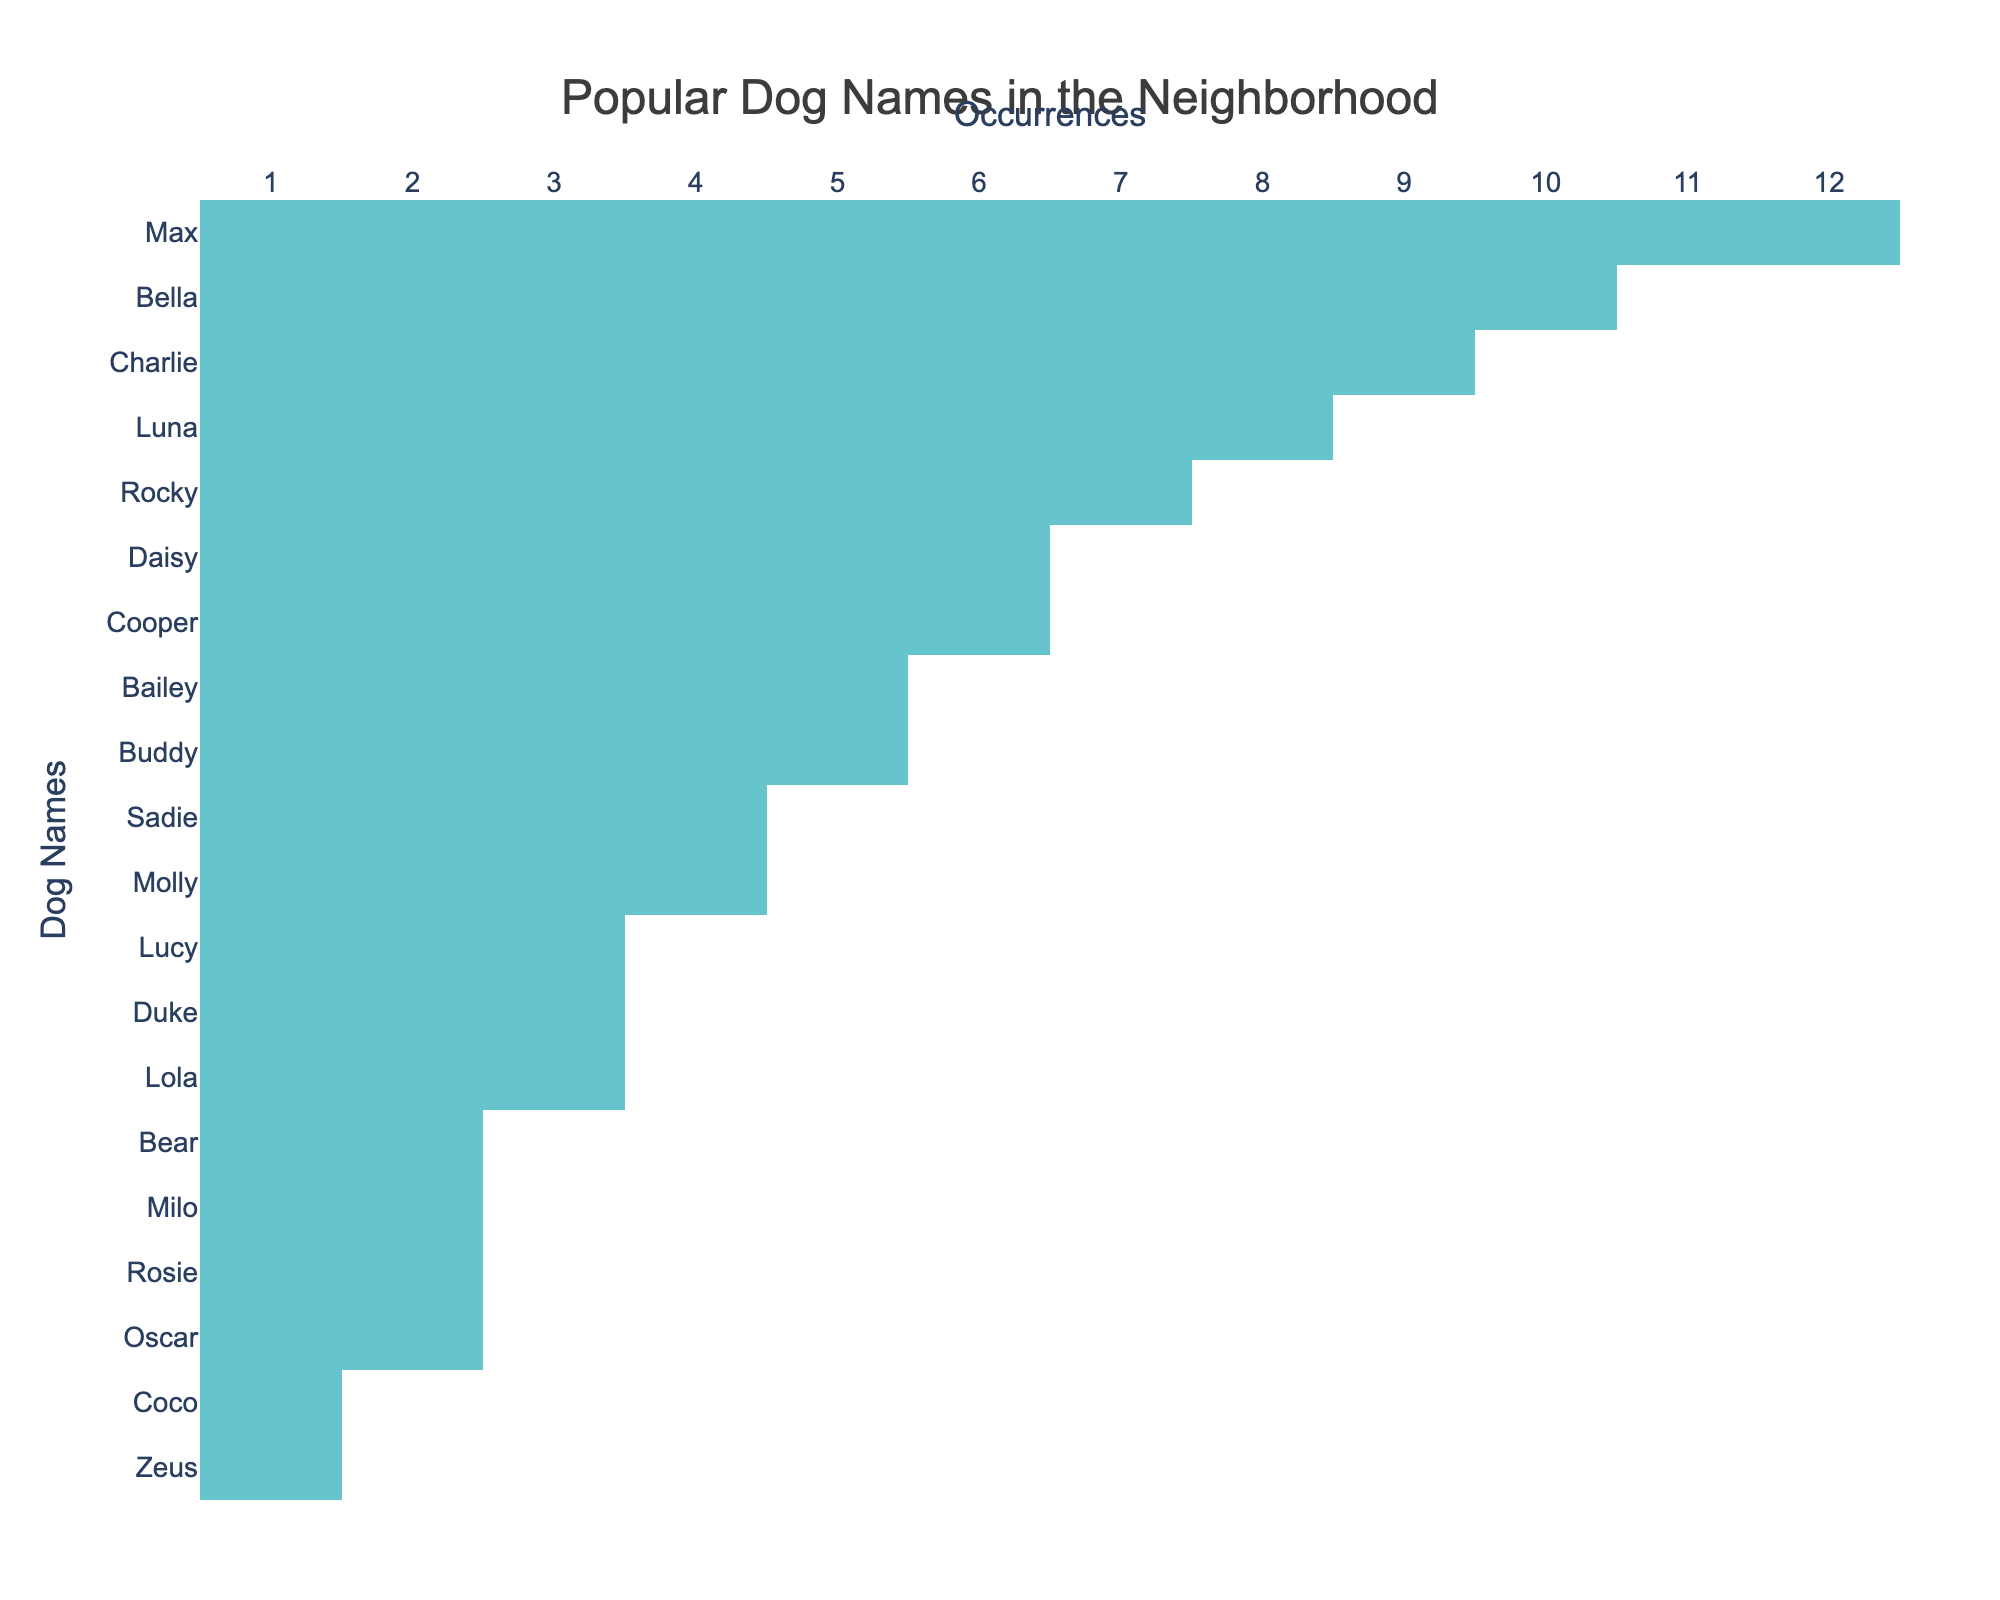What is the most popular dog name in the neighborhood? The table shows that "Max" has the highest occurrence at 12, making it the most popular dog name.
Answer: Max How many dogs have names that occur five times or more? By counting the occurrences of names with 5 or more, we see that there are 7 names: Max, Bella, Charlie, Luna, Rocky, Daisy, and Cooper.
Answer: 7 Is "Oscar" one of the top five most common dog names? Looking at the occurrences, "Oscar" has 2 occurrences, which does not place it in the top five names.
Answer: No What is the total number of occurrences of the dog names that end with the letter 'y'? The names ending with 'y' are Bailey, Buddy, and Daisy. Their occurrences are 5, 5, and 6, respectively. Adding these gives total occurrences as 5 + 5 + 6 = 16.
Answer: 16 What is the difference in occurrences between the most popular and the least popular dog name? The most popular name is "Max" with 12 occurrences and the least popular is "Coco" with 1 occurrence. The difference is 12 - 1 = 11.
Answer: 11 How many names have occurrences of less than 3? The names with occurrences less than 3 are "Coco" and "Zeus." Since there are only 2 names that fit this criterion, the answer is 2.
Answer: 2 Which dog name has the same number of occurrences as "Milo"? "Bear" and "Rosie" each have 2 occurrences, which is the same as "Milo."
Answer: Bear and Rosie If we average the occurrences of the top three names, what do we get? The top three names are Max (12), Bella (10), and Charlie (9). The average occurrence is (12 + 10 + 9) / 3 = 10.33.
Answer: 10.33 Which names have occurrences greater than or equal to 6 but less than 10? The names fitting this criterion are Rocky (7), Daisy (6), and Cooper (6). This gives us a total of 3 names in this range.
Answer: 3 Is there a tie in the number of occurrences among any dog names? Yes, "Cooper" and "Daisy" both occur 6 times, indicating a tie.
Answer: Yes 